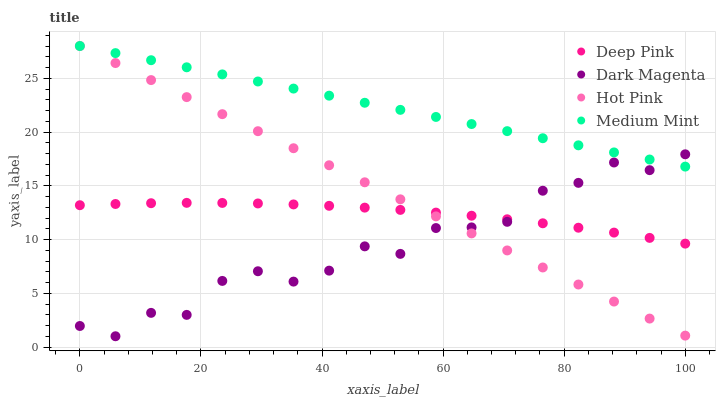Does Dark Magenta have the minimum area under the curve?
Answer yes or no. Yes. Does Medium Mint have the maximum area under the curve?
Answer yes or no. Yes. Does Deep Pink have the minimum area under the curve?
Answer yes or no. No. Does Deep Pink have the maximum area under the curve?
Answer yes or no. No. Is Medium Mint the smoothest?
Answer yes or no. Yes. Is Dark Magenta the roughest?
Answer yes or no. Yes. Is Deep Pink the smoothest?
Answer yes or no. No. Is Deep Pink the roughest?
Answer yes or no. No. Does Dark Magenta have the lowest value?
Answer yes or no. Yes. Does Deep Pink have the lowest value?
Answer yes or no. No. Does Hot Pink have the highest value?
Answer yes or no. Yes. Does Dark Magenta have the highest value?
Answer yes or no. No. Is Deep Pink less than Medium Mint?
Answer yes or no. Yes. Is Medium Mint greater than Deep Pink?
Answer yes or no. Yes. Does Deep Pink intersect Dark Magenta?
Answer yes or no. Yes. Is Deep Pink less than Dark Magenta?
Answer yes or no. No. Is Deep Pink greater than Dark Magenta?
Answer yes or no. No. Does Deep Pink intersect Medium Mint?
Answer yes or no. No. 